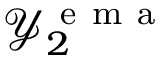Convert formula to latex. <formula><loc_0><loc_0><loc_500><loc_500>\mathcal { Y } _ { 2 } ^ { e m a }</formula> 